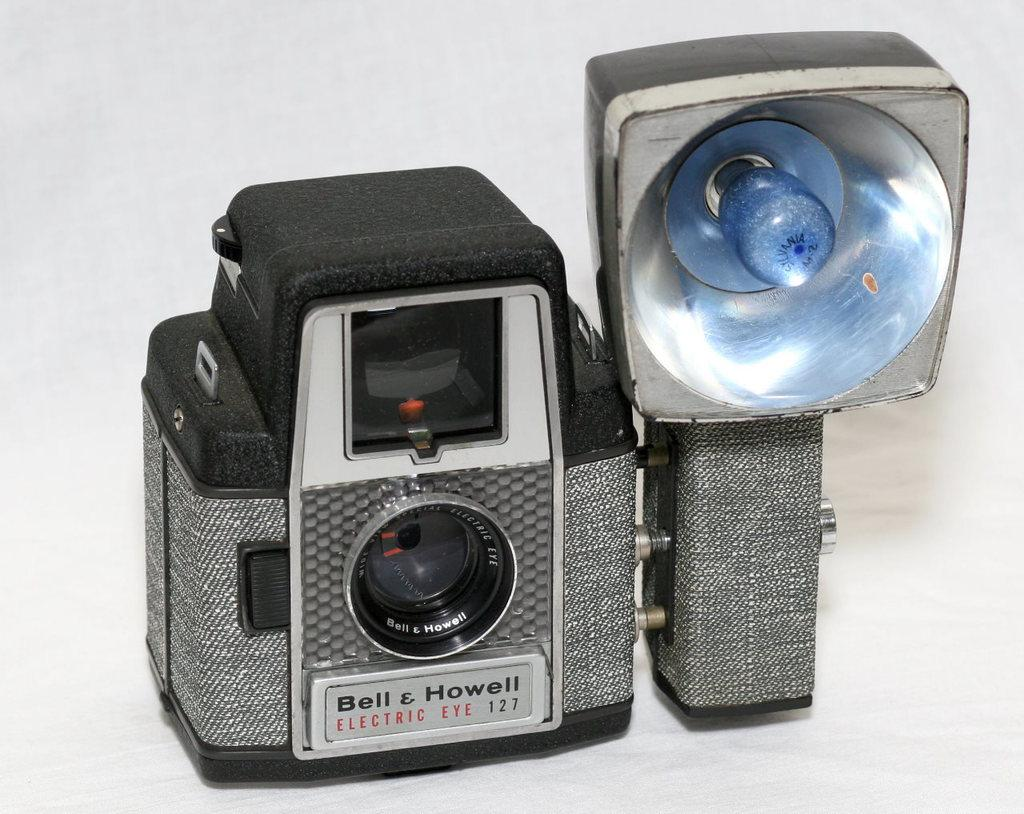<image>
Summarize the visual content of the image. Gray and black camera which says "Bell & Howell" on it. 